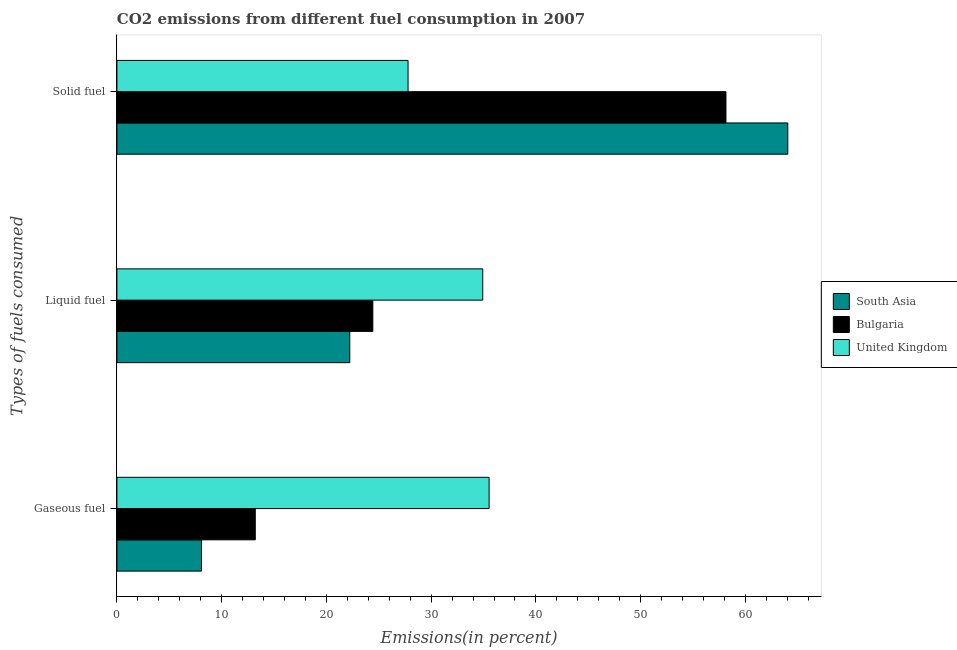How many groups of bars are there?
Make the answer very short. 3. Are the number of bars on each tick of the Y-axis equal?
Offer a terse response. Yes. How many bars are there on the 3rd tick from the top?
Offer a terse response. 3. How many bars are there on the 3rd tick from the bottom?
Offer a terse response. 3. What is the label of the 1st group of bars from the top?
Provide a short and direct response. Solid fuel. What is the percentage of gaseous fuel emission in United Kingdom?
Provide a succinct answer. 35.53. Across all countries, what is the maximum percentage of solid fuel emission?
Ensure brevity in your answer.  64.05. Across all countries, what is the minimum percentage of solid fuel emission?
Provide a succinct answer. 27.79. In which country was the percentage of solid fuel emission maximum?
Offer a terse response. South Asia. In which country was the percentage of gaseous fuel emission minimum?
Provide a short and direct response. South Asia. What is the total percentage of solid fuel emission in the graph?
Provide a succinct answer. 149.98. What is the difference between the percentage of gaseous fuel emission in South Asia and that in United Kingdom?
Offer a terse response. -27.46. What is the difference between the percentage of liquid fuel emission in South Asia and the percentage of solid fuel emission in United Kingdom?
Your answer should be very brief. -5.56. What is the average percentage of liquid fuel emission per country?
Your answer should be compact. 27.2. What is the difference between the percentage of liquid fuel emission and percentage of gaseous fuel emission in United Kingdom?
Offer a terse response. -0.61. In how many countries, is the percentage of solid fuel emission greater than 38 %?
Offer a terse response. 2. What is the ratio of the percentage of liquid fuel emission in South Asia to that in Bulgaria?
Provide a succinct answer. 0.91. Is the percentage of gaseous fuel emission in South Asia less than that in Bulgaria?
Your answer should be compact. Yes. Is the difference between the percentage of solid fuel emission in South Asia and Bulgaria greater than the difference between the percentage of liquid fuel emission in South Asia and Bulgaria?
Ensure brevity in your answer.  Yes. What is the difference between the highest and the second highest percentage of solid fuel emission?
Give a very brief answer. 5.9. What is the difference between the highest and the lowest percentage of liquid fuel emission?
Your answer should be very brief. 12.69. What does the 1st bar from the bottom in Gaseous fuel represents?
Your answer should be compact. South Asia. Is it the case that in every country, the sum of the percentage of gaseous fuel emission and percentage of liquid fuel emission is greater than the percentage of solid fuel emission?
Ensure brevity in your answer.  No. How many countries are there in the graph?
Make the answer very short. 3. What is the difference between two consecutive major ticks on the X-axis?
Ensure brevity in your answer.  10. Are the values on the major ticks of X-axis written in scientific E-notation?
Ensure brevity in your answer.  No. Does the graph contain any zero values?
Provide a succinct answer. No. Where does the legend appear in the graph?
Offer a very short reply. Center right. How many legend labels are there?
Your response must be concise. 3. How are the legend labels stacked?
Offer a terse response. Vertical. What is the title of the graph?
Your answer should be very brief. CO2 emissions from different fuel consumption in 2007. Does "Egypt, Arab Rep." appear as one of the legend labels in the graph?
Provide a succinct answer. No. What is the label or title of the X-axis?
Your answer should be compact. Emissions(in percent). What is the label or title of the Y-axis?
Provide a short and direct response. Types of fuels consumed. What is the Emissions(in percent) in South Asia in Gaseous fuel?
Keep it short and to the point. 8.08. What is the Emissions(in percent) of Bulgaria in Gaseous fuel?
Give a very brief answer. 13.21. What is the Emissions(in percent) in United Kingdom in Gaseous fuel?
Your response must be concise. 35.53. What is the Emissions(in percent) in South Asia in Liquid fuel?
Offer a very short reply. 22.23. What is the Emissions(in percent) of Bulgaria in Liquid fuel?
Ensure brevity in your answer.  24.43. What is the Emissions(in percent) in United Kingdom in Liquid fuel?
Make the answer very short. 34.93. What is the Emissions(in percent) in South Asia in Solid fuel?
Provide a short and direct response. 64.05. What is the Emissions(in percent) of Bulgaria in Solid fuel?
Your answer should be compact. 58.14. What is the Emissions(in percent) in United Kingdom in Solid fuel?
Provide a succinct answer. 27.79. Across all Types of fuels consumed, what is the maximum Emissions(in percent) in South Asia?
Offer a very short reply. 64.05. Across all Types of fuels consumed, what is the maximum Emissions(in percent) of Bulgaria?
Offer a very short reply. 58.14. Across all Types of fuels consumed, what is the maximum Emissions(in percent) in United Kingdom?
Ensure brevity in your answer.  35.53. Across all Types of fuels consumed, what is the minimum Emissions(in percent) in South Asia?
Your answer should be very brief. 8.08. Across all Types of fuels consumed, what is the minimum Emissions(in percent) in Bulgaria?
Offer a terse response. 13.21. Across all Types of fuels consumed, what is the minimum Emissions(in percent) of United Kingdom?
Provide a short and direct response. 27.79. What is the total Emissions(in percent) in South Asia in the graph?
Keep it short and to the point. 94.35. What is the total Emissions(in percent) of Bulgaria in the graph?
Provide a short and direct response. 95.78. What is the total Emissions(in percent) of United Kingdom in the graph?
Your answer should be very brief. 98.25. What is the difference between the Emissions(in percent) of South Asia in Gaseous fuel and that in Liquid fuel?
Offer a very short reply. -14.16. What is the difference between the Emissions(in percent) in Bulgaria in Gaseous fuel and that in Liquid fuel?
Provide a succinct answer. -11.22. What is the difference between the Emissions(in percent) of United Kingdom in Gaseous fuel and that in Liquid fuel?
Give a very brief answer. 0.61. What is the difference between the Emissions(in percent) in South Asia in Gaseous fuel and that in Solid fuel?
Your response must be concise. -55.97. What is the difference between the Emissions(in percent) of Bulgaria in Gaseous fuel and that in Solid fuel?
Provide a short and direct response. -44.93. What is the difference between the Emissions(in percent) of United Kingdom in Gaseous fuel and that in Solid fuel?
Provide a succinct answer. 7.74. What is the difference between the Emissions(in percent) of South Asia in Liquid fuel and that in Solid fuel?
Provide a short and direct response. -41.82. What is the difference between the Emissions(in percent) in Bulgaria in Liquid fuel and that in Solid fuel?
Provide a succinct answer. -33.71. What is the difference between the Emissions(in percent) in United Kingdom in Liquid fuel and that in Solid fuel?
Provide a short and direct response. 7.13. What is the difference between the Emissions(in percent) of South Asia in Gaseous fuel and the Emissions(in percent) of Bulgaria in Liquid fuel?
Give a very brief answer. -16.36. What is the difference between the Emissions(in percent) in South Asia in Gaseous fuel and the Emissions(in percent) in United Kingdom in Liquid fuel?
Provide a short and direct response. -26.85. What is the difference between the Emissions(in percent) in Bulgaria in Gaseous fuel and the Emissions(in percent) in United Kingdom in Liquid fuel?
Your answer should be compact. -21.72. What is the difference between the Emissions(in percent) in South Asia in Gaseous fuel and the Emissions(in percent) in Bulgaria in Solid fuel?
Give a very brief answer. -50.07. What is the difference between the Emissions(in percent) in South Asia in Gaseous fuel and the Emissions(in percent) in United Kingdom in Solid fuel?
Provide a succinct answer. -19.72. What is the difference between the Emissions(in percent) of Bulgaria in Gaseous fuel and the Emissions(in percent) of United Kingdom in Solid fuel?
Ensure brevity in your answer.  -14.58. What is the difference between the Emissions(in percent) of South Asia in Liquid fuel and the Emissions(in percent) of Bulgaria in Solid fuel?
Your answer should be very brief. -35.91. What is the difference between the Emissions(in percent) in South Asia in Liquid fuel and the Emissions(in percent) in United Kingdom in Solid fuel?
Offer a very short reply. -5.56. What is the difference between the Emissions(in percent) of Bulgaria in Liquid fuel and the Emissions(in percent) of United Kingdom in Solid fuel?
Provide a succinct answer. -3.36. What is the average Emissions(in percent) in South Asia per Types of fuels consumed?
Your response must be concise. 31.45. What is the average Emissions(in percent) of Bulgaria per Types of fuels consumed?
Provide a short and direct response. 31.93. What is the average Emissions(in percent) of United Kingdom per Types of fuels consumed?
Provide a succinct answer. 32.75. What is the difference between the Emissions(in percent) of South Asia and Emissions(in percent) of Bulgaria in Gaseous fuel?
Make the answer very short. -5.13. What is the difference between the Emissions(in percent) in South Asia and Emissions(in percent) in United Kingdom in Gaseous fuel?
Keep it short and to the point. -27.46. What is the difference between the Emissions(in percent) in Bulgaria and Emissions(in percent) in United Kingdom in Gaseous fuel?
Your answer should be compact. -22.32. What is the difference between the Emissions(in percent) of South Asia and Emissions(in percent) of Bulgaria in Liquid fuel?
Your response must be concise. -2.2. What is the difference between the Emissions(in percent) in South Asia and Emissions(in percent) in United Kingdom in Liquid fuel?
Your answer should be very brief. -12.7. What is the difference between the Emissions(in percent) of Bulgaria and Emissions(in percent) of United Kingdom in Liquid fuel?
Give a very brief answer. -10.49. What is the difference between the Emissions(in percent) of South Asia and Emissions(in percent) of Bulgaria in Solid fuel?
Offer a terse response. 5.9. What is the difference between the Emissions(in percent) in South Asia and Emissions(in percent) in United Kingdom in Solid fuel?
Your response must be concise. 36.25. What is the difference between the Emissions(in percent) of Bulgaria and Emissions(in percent) of United Kingdom in Solid fuel?
Give a very brief answer. 30.35. What is the ratio of the Emissions(in percent) of South Asia in Gaseous fuel to that in Liquid fuel?
Give a very brief answer. 0.36. What is the ratio of the Emissions(in percent) in Bulgaria in Gaseous fuel to that in Liquid fuel?
Make the answer very short. 0.54. What is the ratio of the Emissions(in percent) of United Kingdom in Gaseous fuel to that in Liquid fuel?
Your answer should be compact. 1.02. What is the ratio of the Emissions(in percent) of South Asia in Gaseous fuel to that in Solid fuel?
Provide a succinct answer. 0.13. What is the ratio of the Emissions(in percent) of Bulgaria in Gaseous fuel to that in Solid fuel?
Provide a short and direct response. 0.23. What is the ratio of the Emissions(in percent) in United Kingdom in Gaseous fuel to that in Solid fuel?
Offer a terse response. 1.28. What is the ratio of the Emissions(in percent) in South Asia in Liquid fuel to that in Solid fuel?
Give a very brief answer. 0.35. What is the ratio of the Emissions(in percent) of Bulgaria in Liquid fuel to that in Solid fuel?
Your answer should be compact. 0.42. What is the ratio of the Emissions(in percent) in United Kingdom in Liquid fuel to that in Solid fuel?
Your answer should be very brief. 1.26. What is the difference between the highest and the second highest Emissions(in percent) of South Asia?
Make the answer very short. 41.82. What is the difference between the highest and the second highest Emissions(in percent) in Bulgaria?
Make the answer very short. 33.71. What is the difference between the highest and the second highest Emissions(in percent) in United Kingdom?
Ensure brevity in your answer.  0.61. What is the difference between the highest and the lowest Emissions(in percent) in South Asia?
Offer a very short reply. 55.97. What is the difference between the highest and the lowest Emissions(in percent) of Bulgaria?
Offer a very short reply. 44.93. What is the difference between the highest and the lowest Emissions(in percent) in United Kingdom?
Provide a short and direct response. 7.74. 